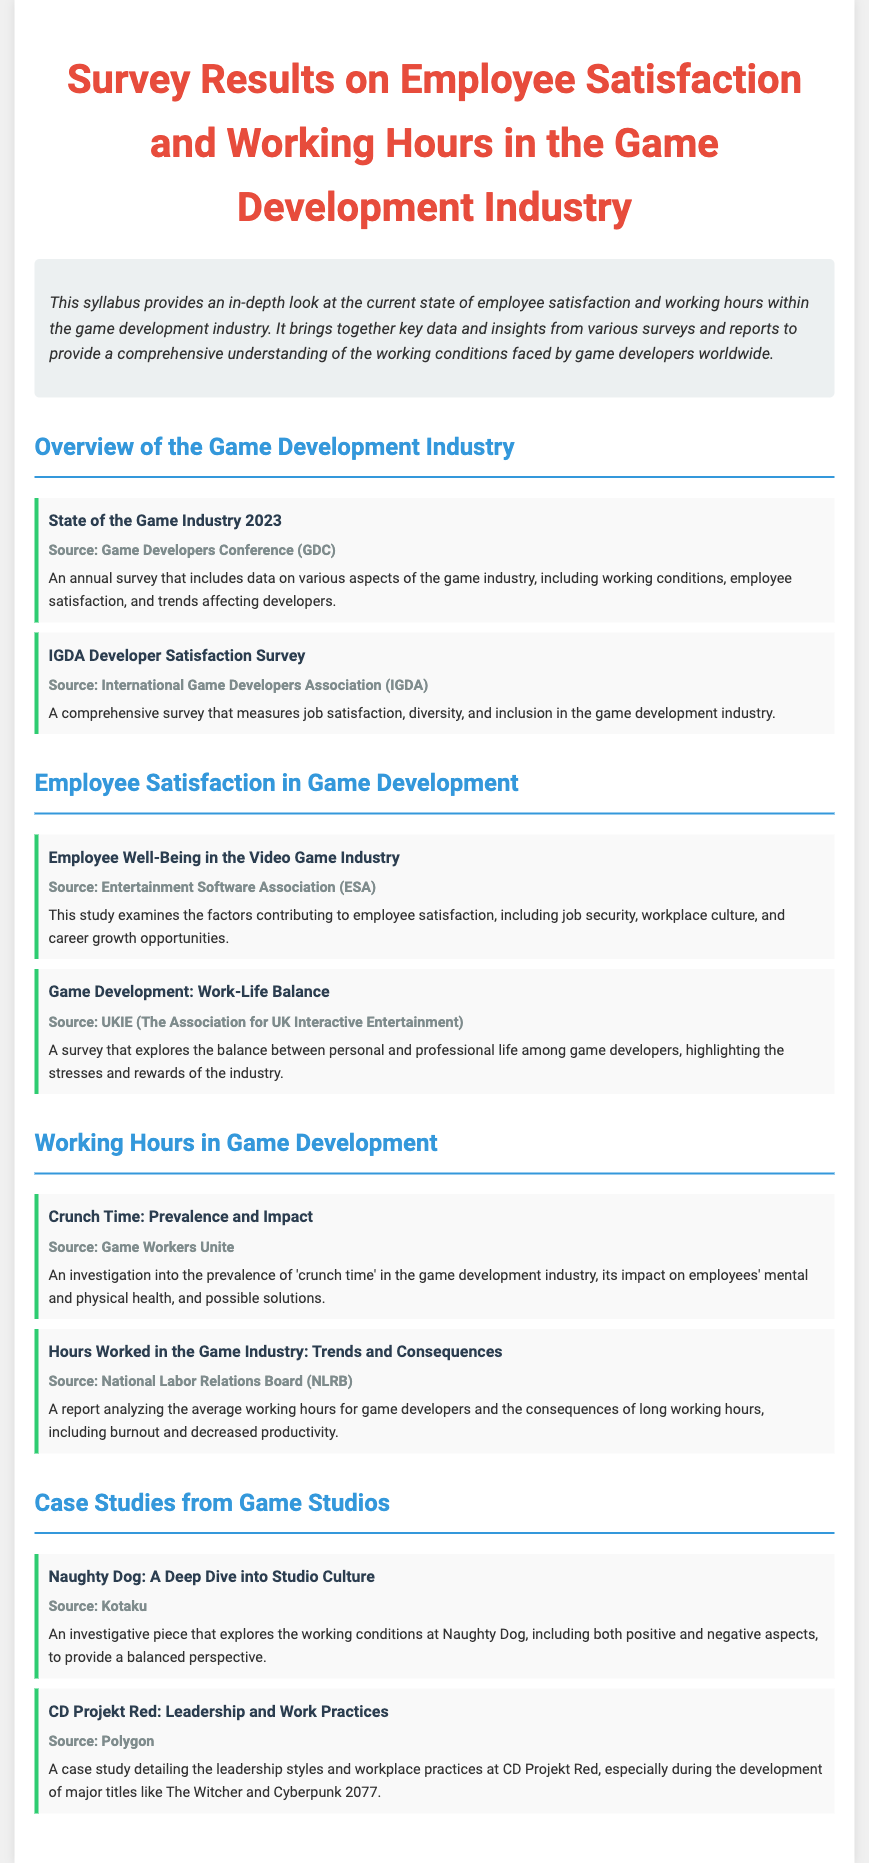What is the title of the syllabus? The title is stated at the very beginning of the document, summarizing the content regarding the game development industry.
Answer: Survey Results on Employee Satisfaction and Working Hours in the Game Development Industry Which organization conducted the annual survey mentioned in the overview section? The source of the annual survey is listed, identifying the organization that conducted it for insights into the game industry.
Answer: Game Developers Conference (GDC) What survey measures job satisfaction in the game industry? The document specifies different surveys and reports; one explicitly focuses on measuring job satisfaction.
Answer: IGDA Developer Satisfaction Survey What year is referenced in the overview of the game industry? The syllabus provides an indication of the current year in which the state of the industry is discussed.
Answer: 2023 What is a major issue investigated in the 'Crunch Time' section? This section examines the implications of a specific work practice within the industry that affects employee health.
Answer: Prevalence and Impact Name one factor contributing to employee satisfaction highlighted in the document. The document lists contributors to employee satisfaction, and one of them is explicitly mentioned in an overview.
Answer: Job security Which studio is the focus of a case study regarding its culture? The syllabus includes a deep dive into a well-known studio, with an investigation into its working conditions.
Answer: Naughty Dog How does the survey discussed in the document measure the working hours of game developers? The document references a report that analyzes a specific aspect of the working conditions.
Answer: Trends and Consequences What does the document indicate is a key focus area in the case studies? The case studies aim to provide insights into a particular aspect of game studios' practices and leadership styles.
Answer: Studio Culture 